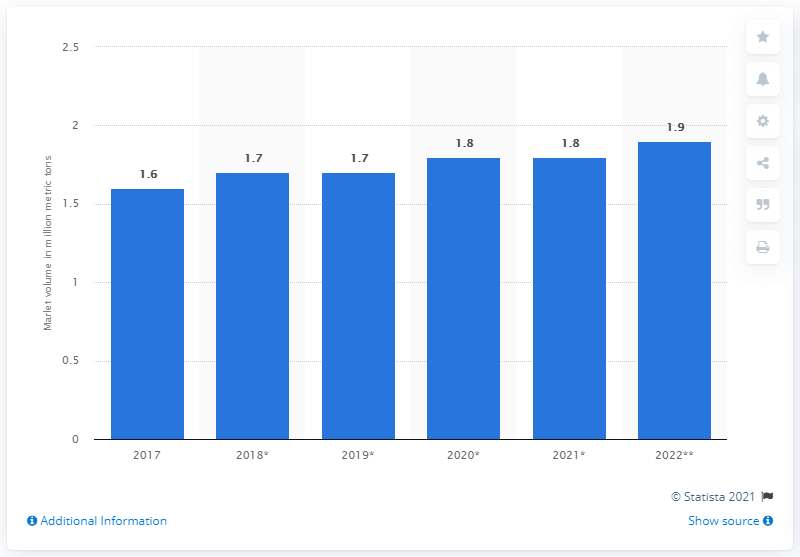Give some essential details in this illustration. According to a 2017 report, the global volume of polyol sweeteners or sugar alcohols was 1.6 million metric tons. 